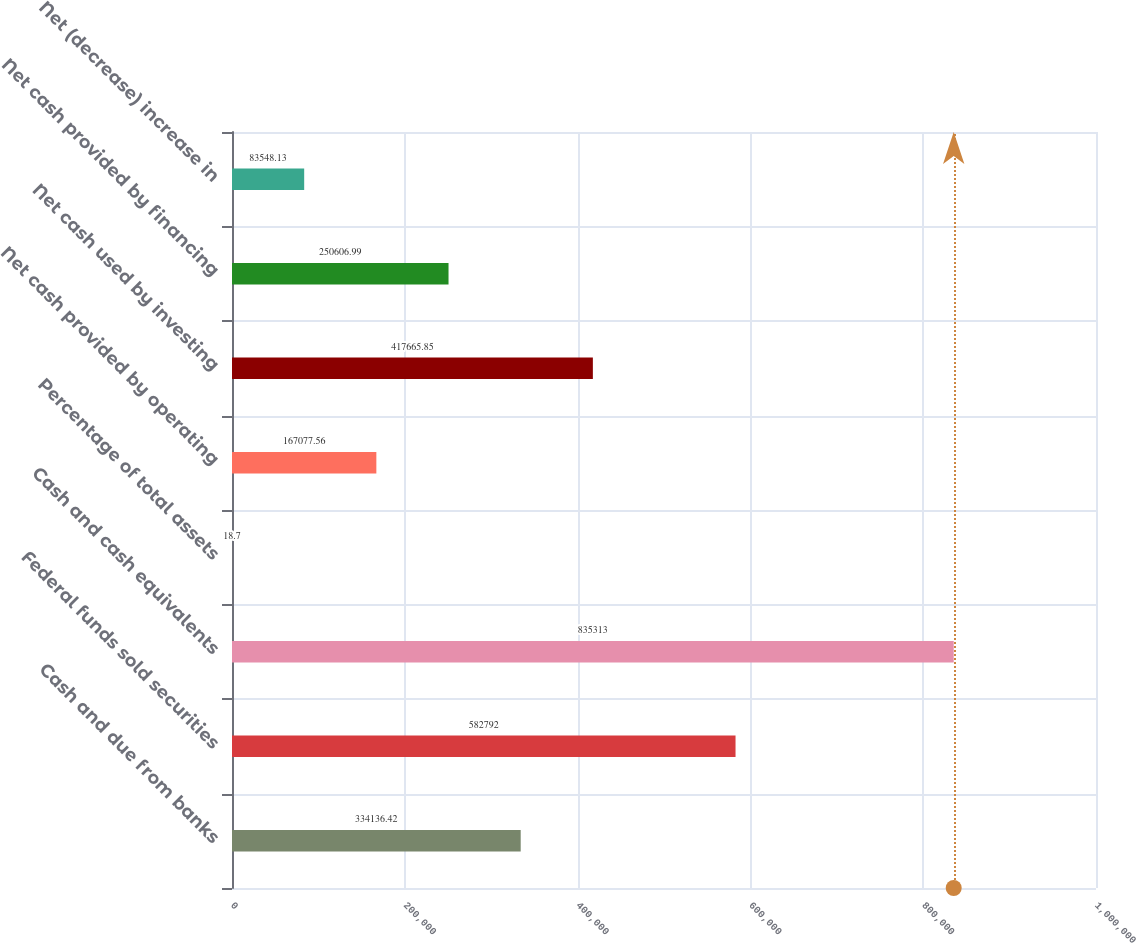<chart> <loc_0><loc_0><loc_500><loc_500><bar_chart><fcel>Cash and due from banks<fcel>Federal funds sold securities<fcel>Cash and cash equivalents<fcel>Percentage of total assets<fcel>Net cash provided by operating<fcel>Net cash used by investing<fcel>Net cash provided by financing<fcel>Net (decrease) increase in<nl><fcel>334136<fcel>582792<fcel>835313<fcel>18.7<fcel>167078<fcel>417666<fcel>250607<fcel>83548.1<nl></chart> 